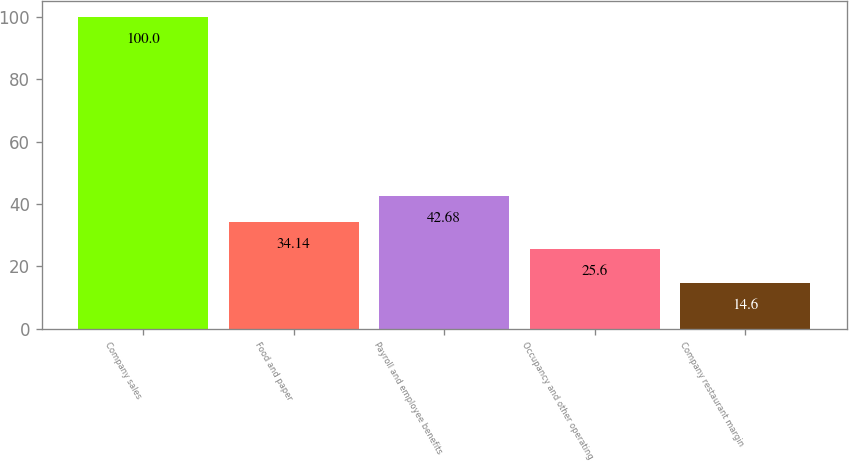<chart> <loc_0><loc_0><loc_500><loc_500><bar_chart><fcel>Company sales<fcel>Food and paper<fcel>Payroll and employee benefits<fcel>Occupancy and other operating<fcel>Company restaurant margin<nl><fcel>100<fcel>34.14<fcel>42.68<fcel>25.6<fcel>14.6<nl></chart> 